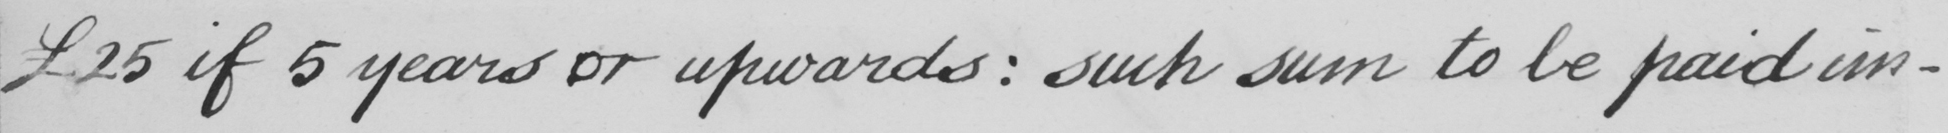Transcribe the text shown in this historical manuscript line. £25 if 5 years or upwards :  such seem to be paid im- 